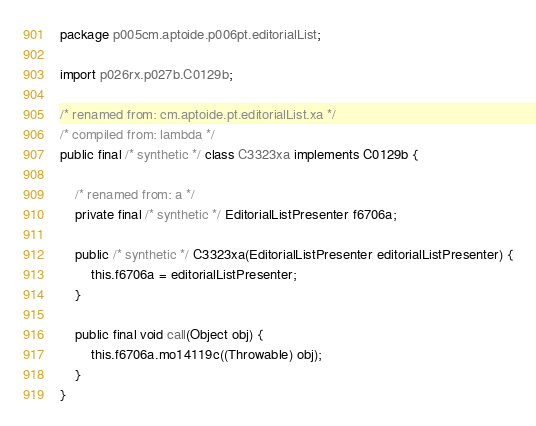Convert code to text. <code><loc_0><loc_0><loc_500><loc_500><_Java_>package p005cm.aptoide.p006pt.editorialList;

import p026rx.p027b.C0129b;

/* renamed from: cm.aptoide.pt.editorialList.xa */
/* compiled from: lambda */
public final /* synthetic */ class C3323xa implements C0129b {

    /* renamed from: a */
    private final /* synthetic */ EditorialListPresenter f6706a;

    public /* synthetic */ C3323xa(EditorialListPresenter editorialListPresenter) {
        this.f6706a = editorialListPresenter;
    }

    public final void call(Object obj) {
        this.f6706a.mo14119c((Throwable) obj);
    }
}
</code> 